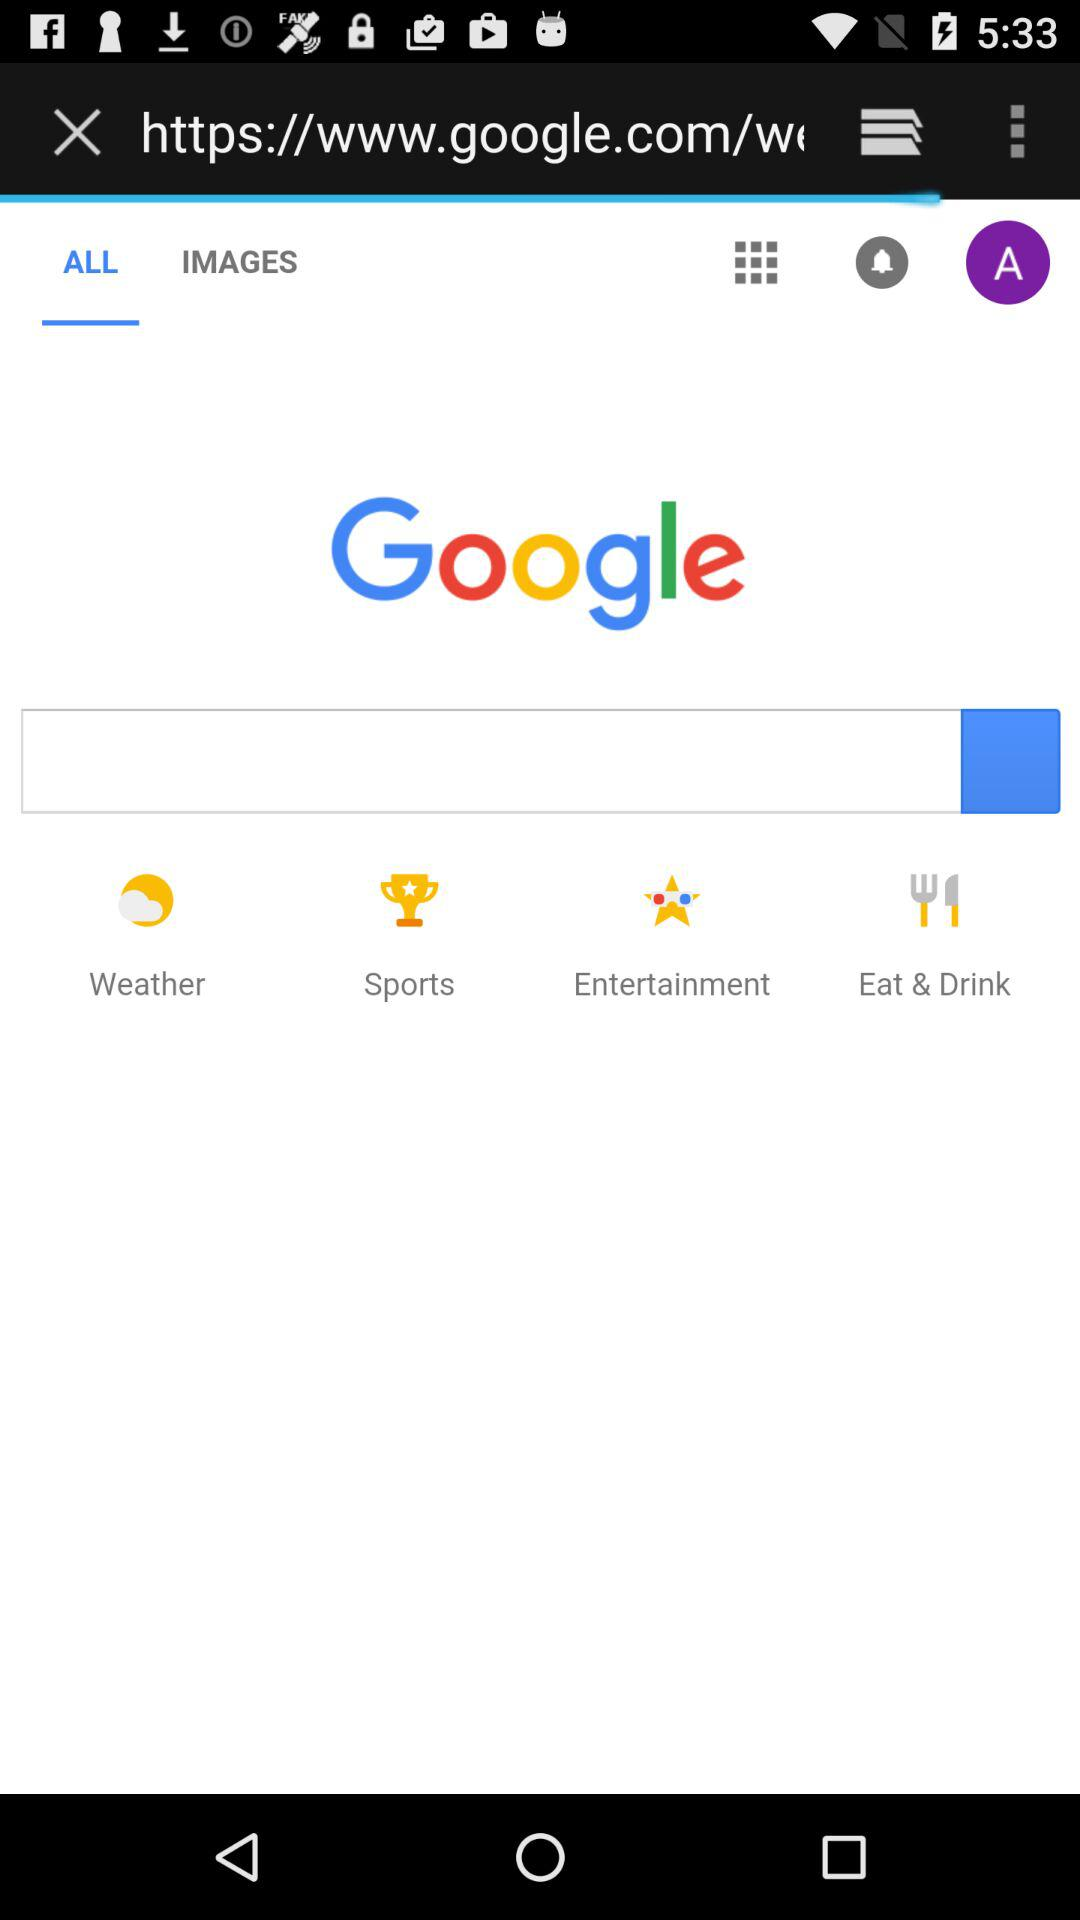Which tab is selected? The selected tab is "ALL". 